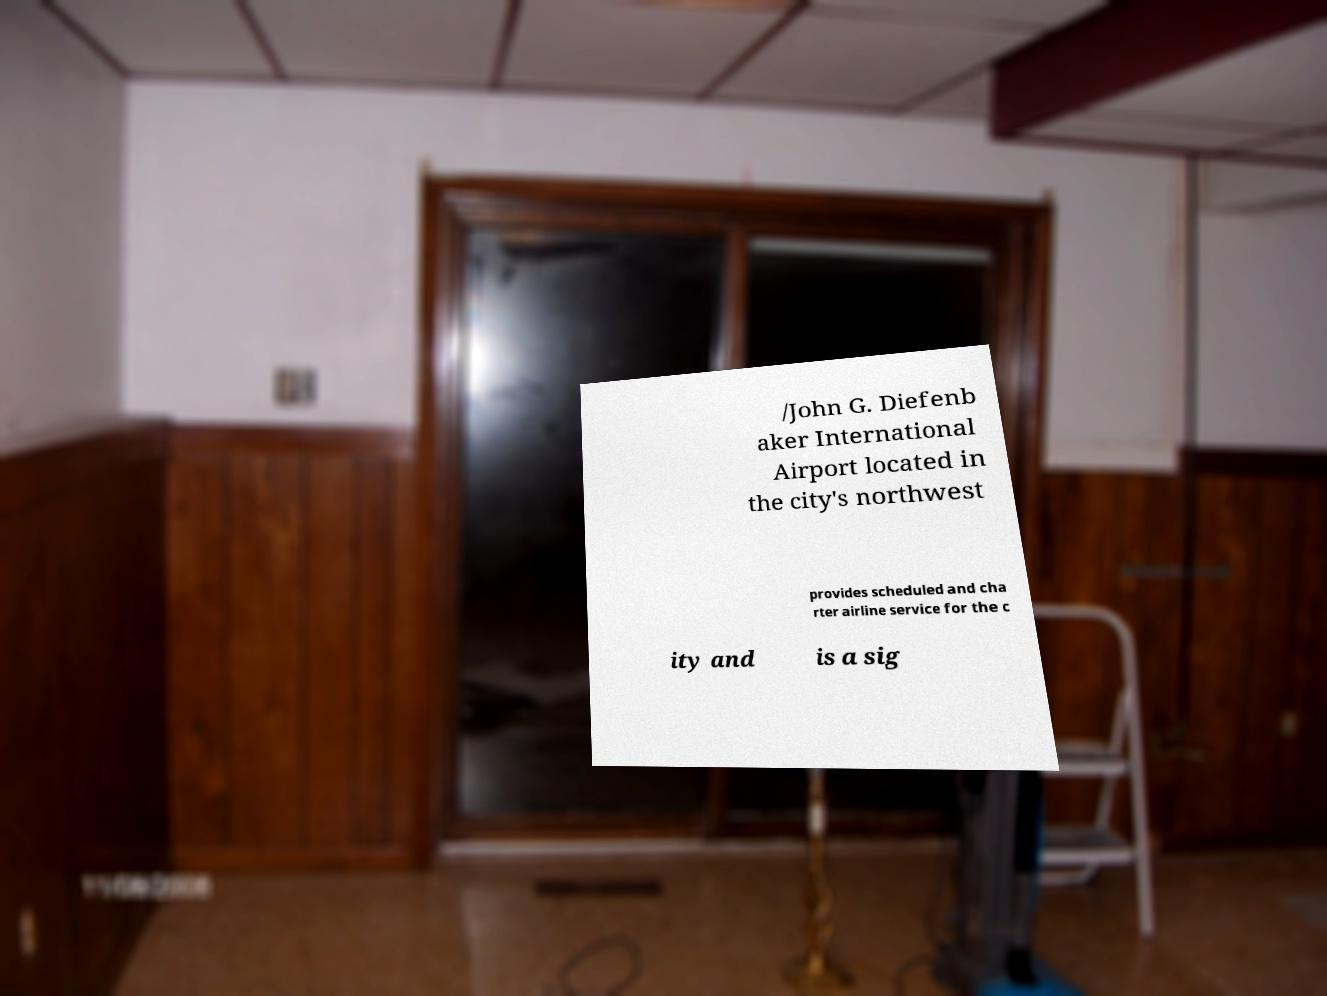Could you assist in decoding the text presented in this image and type it out clearly? /John G. Diefenb aker International Airport located in the city's northwest provides scheduled and cha rter airline service for the c ity and is a sig 